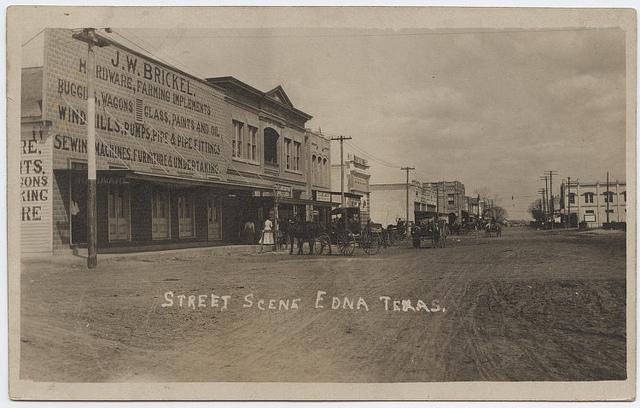Is the photo old?
Give a very brief answer. Yes. What is this a photo of?
Keep it brief. Street scene edna texas. What does it say after street scene?
Give a very brief answer. Edna texas. Is the road paved?
Give a very brief answer. No. 